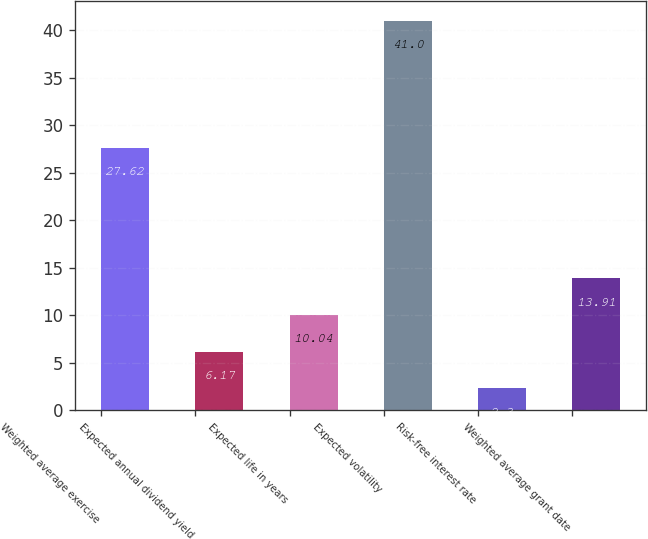Convert chart. <chart><loc_0><loc_0><loc_500><loc_500><bar_chart><fcel>Weighted average exercise<fcel>Expected annual dividend yield<fcel>Expected life in years<fcel>Expected volatility<fcel>Risk-free interest rate<fcel>Weighted average grant date<nl><fcel>27.62<fcel>6.17<fcel>10.04<fcel>41<fcel>2.3<fcel>13.91<nl></chart> 